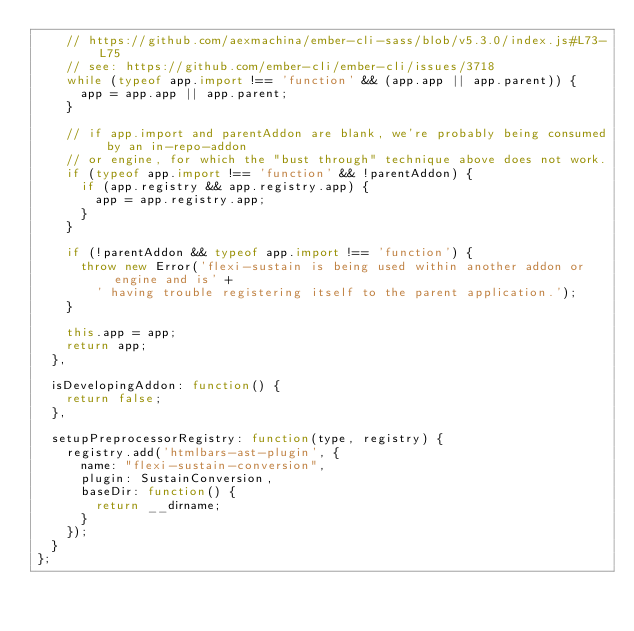<code> <loc_0><loc_0><loc_500><loc_500><_JavaScript_>    // https://github.com/aexmachina/ember-cli-sass/blob/v5.3.0/index.js#L73-L75
    // see: https://github.com/ember-cli/ember-cli/issues/3718
    while (typeof app.import !== 'function' && (app.app || app.parent)) {
      app = app.app || app.parent;
    }

    // if app.import and parentAddon are blank, we're probably being consumed by an in-repo-addon
    // or engine, for which the "bust through" technique above does not work.
    if (typeof app.import !== 'function' && !parentAddon) {
      if (app.registry && app.registry.app) {
        app = app.registry.app;
      }
    }

    if (!parentAddon && typeof app.import !== 'function') {
      throw new Error('flexi-sustain is being used within another addon or engine and is' +
        ' having trouble registering itself to the parent application.');
    }

    this.app = app;
    return app;
  },

  isDevelopingAddon: function() {
    return false;
  },

  setupPreprocessorRegistry: function(type, registry) {
    registry.add('htmlbars-ast-plugin', {
      name: "flexi-sustain-conversion",
      plugin: SustainConversion,
      baseDir: function() {
        return __dirname;
      }
    });
  }
};
</code> 